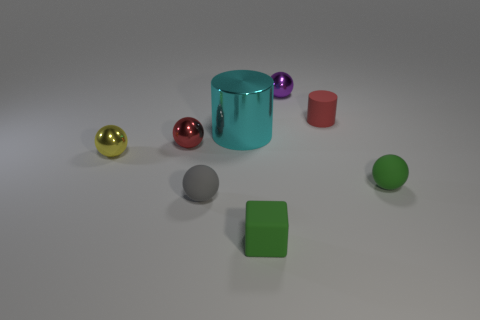Subtract all cyan balls. Subtract all green blocks. How many balls are left? 5 Add 2 big red shiny cubes. How many objects exist? 10 Subtract all balls. How many objects are left? 3 Subtract all small cyan objects. Subtract all tiny yellow balls. How many objects are left? 7 Add 2 yellow spheres. How many yellow spheres are left? 3 Add 4 tiny purple spheres. How many tiny purple spheres exist? 5 Subtract 0 blue cylinders. How many objects are left? 8 